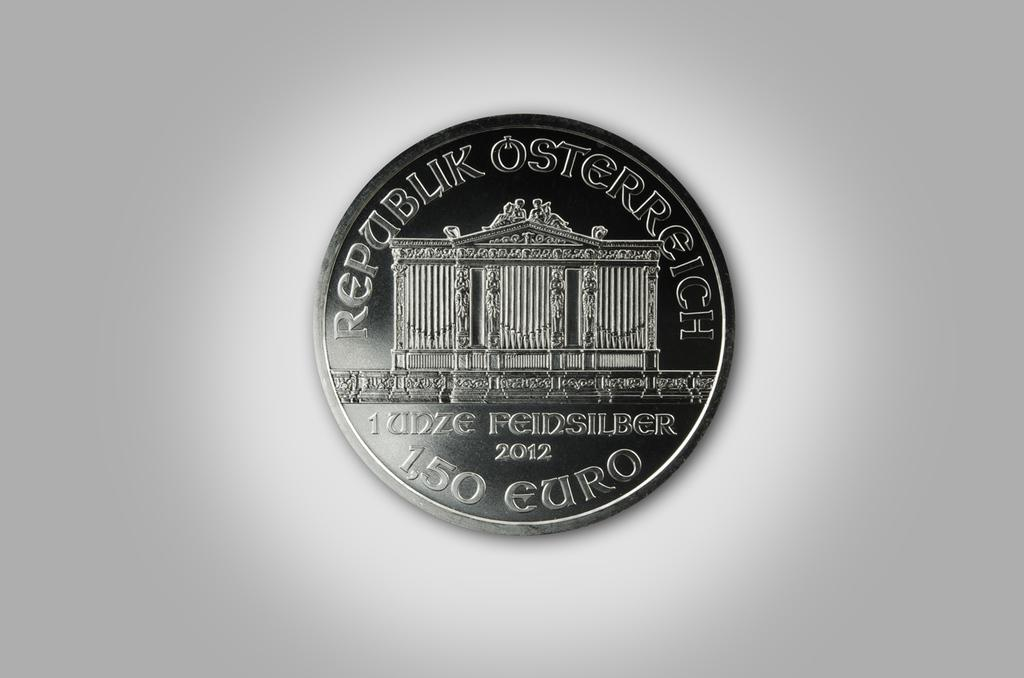<image>
Describe the image concisely. A silver Euro coin with an image of a building on the center. 